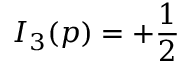<formula> <loc_0><loc_0><loc_500><loc_500>I _ { 3 } ( p ) = + { \frac { 1 } { 2 } }</formula> 